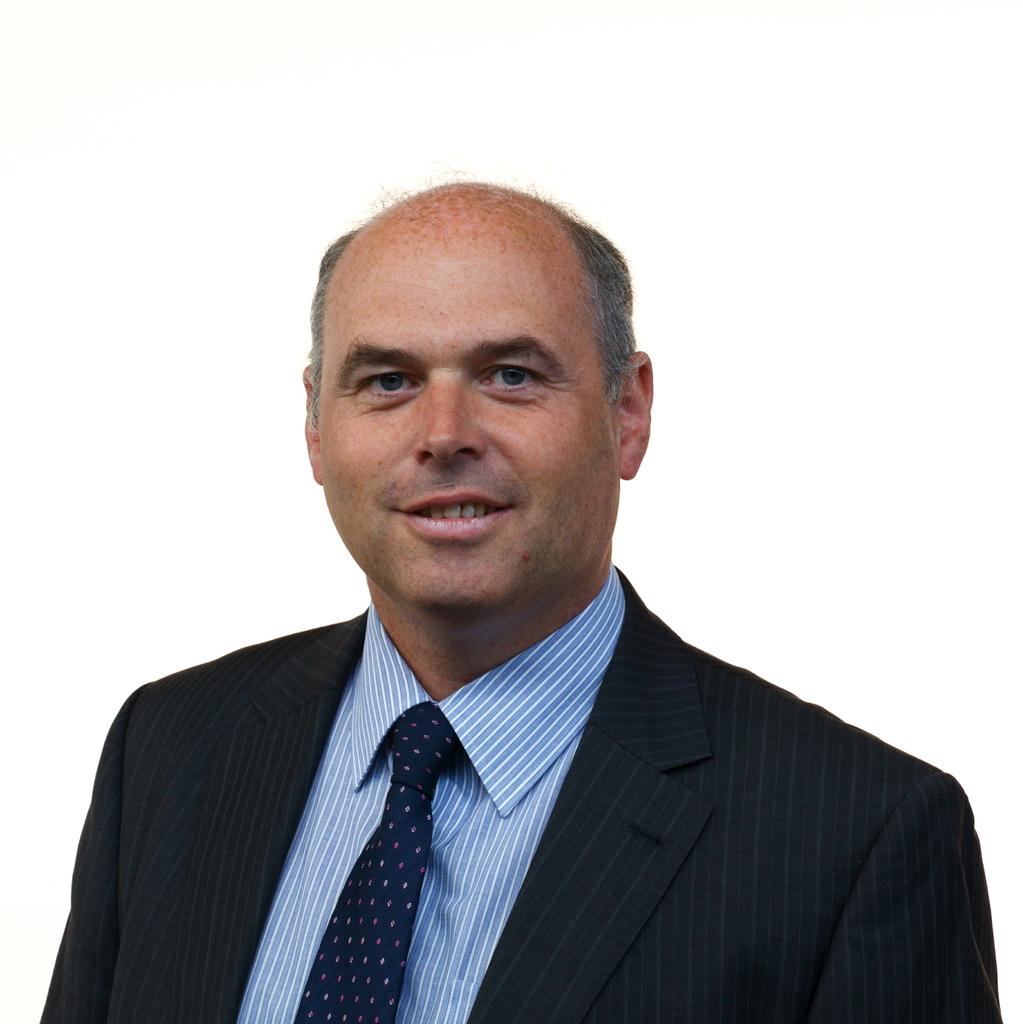Who is present in the image? There is a man in the image. What is the man's facial expression? The man has a smiling face. What is the man wearing on his upper body? The man is wearing a black suit, a tie, and a blue shirt. What type of vest is the man wearing in the image? There is no mention of a vest in the provided facts, so we cannot determine if the man is wearing a vest or not. 